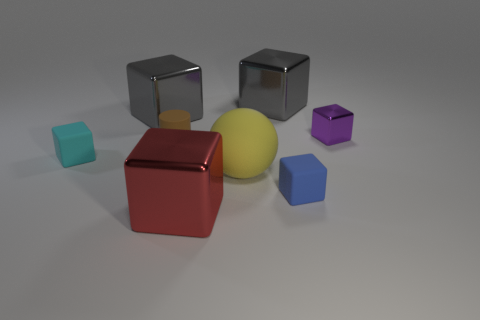Subtract 4 blocks. How many blocks are left? 2 Subtract all red metal cubes. How many cubes are left? 5 Subtract all blue blocks. How many blocks are left? 5 Add 1 red rubber balls. How many objects exist? 9 Subtract all blue cubes. Subtract all blue cylinders. How many cubes are left? 5 Subtract all cylinders. How many objects are left? 7 Subtract 0 yellow blocks. How many objects are left? 8 Subtract all tiny purple balls. Subtract all gray shiny things. How many objects are left? 6 Add 3 red shiny objects. How many red shiny objects are left? 4 Add 7 yellow balls. How many yellow balls exist? 8 